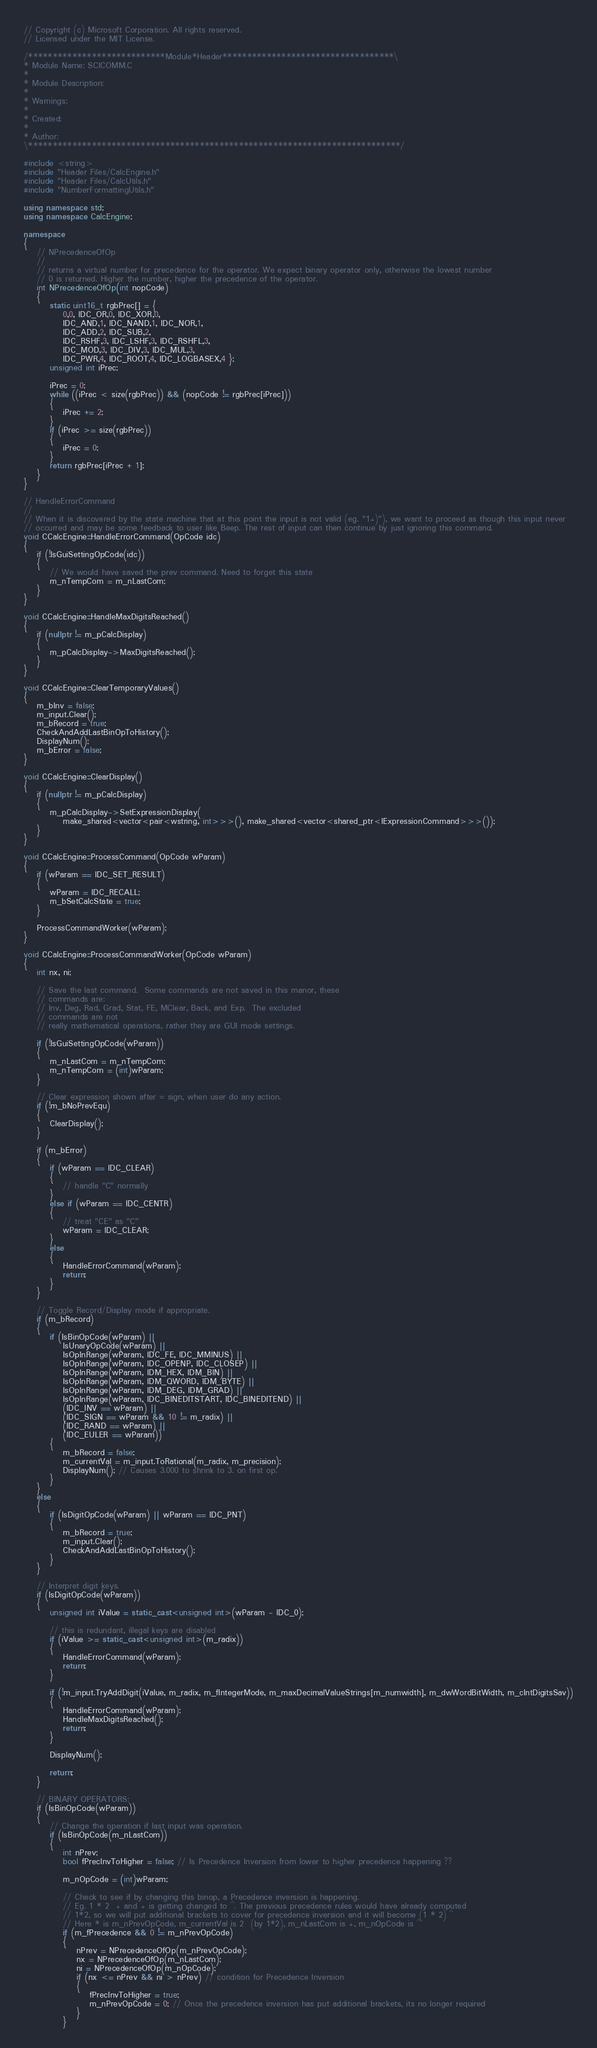<code> <loc_0><loc_0><loc_500><loc_500><_C++_>// Copyright (c) Microsoft Corporation. All rights reserved.
// Licensed under the MIT License.

/****************************Module*Header***********************************\
* Module Name: SCICOMM.C
*
* Module Description:
*
* Warnings:
*
* Created:
*
* Author:
\****************************************************************************/

#include <string>
#include "Header Files/CalcEngine.h"
#include "Header Files/CalcUtils.h"
#include "NumberFormattingUtils.h"

using namespace std;
using namespace CalcEngine;

namespace
{
    // NPrecedenceOfOp
    //
    // returns a virtual number for precedence for the operator. We expect binary operator only, otherwise the lowest number
    // 0 is returned. Higher the number, higher the precedence of the operator.
    int NPrecedenceOfOp(int nopCode)
    {
        static uint16_t rgbPrec[] = {
            0,0, IDC_OR,0, IDC_XOR,0,
            IDC_AND,1, IDC_NAND,1, IDC_NOR,1,
            IDC_ADD,2, IDC_SUB,2,
            IDC_RSHF,3, IDC_LSHF,3, IDC_RSHFL,3,
            IDC_MOD,3, IDC_DIV,3, IDC_MUL,3,
            IDC_PWR,4, IDC_ROOT,4, IDC_LOGBASEX,4 };
        unsigned int iPrec;

        iPrec = 0;
        while ((iPrec < size(rgbPrec)) && (nopCode != rgbPrec[iPrec]))
        {
            iPrec += 2;
        }
        if (iPrec >= size(rgbPrec))
        {
            iPrec = 0;
        }
        return rgbPrec[iPrec + 1];
    }
}

// HandleErrorCommand
//
// When it is discovered by the state machine that at this point the input is not valid (eg. "1+)"), we want to proceed as though this input never
// occurred and may be some feedback to user like Beep. The rest of input can then continue by just ignoring this command.
void CCalcEngine::HandleErrorCommand(OpCode idc)
{
    if (!IsGuiSettingOpCode(idc))
    {
        // We would have saved the prev command. Need to forget this state
        m_nTempCom = m_nLastCom;
    }
}

void CCalcEngine::HandleMaxDigitsReached()
{
    if (nullptr != m_pCalcDisplay)
    {
        m_pCalcDisplay->MaxDigitsReached();
    }
}

void CCalcEngine::ClearTemporaryValues()
{
    m_bInv = false;
    m_input.Clear();
    m_bRecord = true;
    CheckAndAddLastBinOpToHistory();
    DisplayNum();
    m_bError = false;
}

void CCalcEngine::ClearDisplay()
{
    if (nullptr != m_pCalcDisplay)
    {
        m_pCalcDisplay->SetExpressionDisplay(
            make_shared<vector<pair<wstring, int>>>(), make_shared<vector<shared_ptr<IExpressionCommand>>>());
    }
}

void CCalcEngine::ProcessCommand(OpCode wParam)
{
    if (wParam == IDC_SET_RESULT)
    {
        wParam = IDC_RECALL;
        m_bSetCalcState = true;
    }

    ProcessCommandWorker(wParam);
}

void CCalcEngine::ProcessCommandWorker(OpCode wParam)
{
    int nx, ni;

    // Save the last command.  Some commands are not saved in this manor, these
    // commands are:
    // Inv, Deg, Rad, Grad, Stat, FE, MClear, Back, and Exp.  The excluded
    // commands are not
    // really mathematical operations, rather they are GUI mode settings.

    if (!IsGuiSettingOpCode(wParam))
    {
        m_nLastCom = m_nTempCom;
        m_nTempCom = (int)wParam;
    }

    // Clear expression shown after = sign, when user do any action.
    if (!m_bNoPrevEqu)
    {
        ClearDisplay();
    }

    if (m_bError)
    {
        if (wParam == IDC_CLEAR)
        {
            // handle "C" normally
        }
        else if (wParam == IDC_CENTR)
        {
            // treat "CE" as "C"
            wParam = IDC_CLEAR;
        }
        else
        {
            HandleErrorCommand(wParam);
            return;
        }
    }

    // Toggle Record/Display mode if appropriate.
    if (m_bRecord)
    {
        if (IsBinOpCode(wParam) ||
            IsUnaryOpCode(wParam) ||
            IsOpInRange(wParam, IDC_FE, IDC_MMINUS) ||
            IsOpInRange(wParam, IDC_OPENP, IDC_CLOSEP) ||
            IsOpInRange(wParam, IDM_HEX, IDM_BIN) ||
            IsOpInRange(wParam, IDM_QWORD, IDM_BYTE) ||
            IsOpInRange(wParam, IDM_DEG, IDM_GRAD) ||
            IsOpInRange(wParam, IDC_BINEDITSTART, IDC_BINEDITEND) ||
            (IDC_INV == wParam) ||
            (IDC_SIGN == wParam && 10 != m_radix) ||
            (IDC_RAND == wParam) ||
            (IDC_EULER == wParam))
        {
            m_bRecord = false;
            m_currentVal = m_input.ToRational(m_radix, m_precision);
            DisplayNum(); // Causes 3.000 to shrink to 3. on first op.
        }
    }
    else
    {
        if (IsDigitOpCode(wParam) || wParam == IDC_PNT)
        {
            m_bRecord = true;
            m_input.Clear();
            CheckAndAddLastBinOpToHistory();
        }
    }

    // Interpret digit keys.
    if (IsDigitOpCode(wParam))
    {
        unsigned int iValue = static_cast<unsigned int>(wParam - IDC_0);

        // this is redundant, illegal keys are disabled
        if (iValue >= static_cast<unsigned int>(m_radix))
        {
            HandleErrorCommand(wParam);
            return;
        }

        if (!m_input.TryAddDigit(iValue, m_radix, m_fIntegerMode, m_maxDecimalValueStrings[m_numwidth], m_dwWordBitWidth, m_cIntDigitsSav))
        {
            HandleErrorCommand(wParam);
            HandleMaxDigitsReached();
            return;
        }

        DisplayNum();

        return;
    }

    // BINARY OPERATORS:
    if (IsBinOpCode(wParam))
    {
        // Change the operation if last input was operation.
        if (IsBinOpCode(m_nLastCom))
        {
            int nPrev;
            bool fPrecInvToHigher = false; // Is Precedence Inversion from lower to higher precedence happening ??

            m_nOpCode = (int)wParam;

            // Check to see if by changing this binop, a Precedence inversion is happening.
            // Eg. 1 * 2  + and + is getting changed to ^. The previous precedence rules would have already computed
            // 1*2, so we will put additional brackets to cover for precedence inversion and it will become (1 * 2) ^
            // Here * is m_nPrevOpCode, m_currentVal is 2  (by 1*2), m_nLastCom is +, m_nOpCode is ^
            if (m_fPrecedence && 0 != m_nPrevOpCode)
            {
                nPrev = NPrecedenceOfOp(m_nPrevOpCode);
                nx = NPrecedenceOfOp(m_nLastCom);
                ni = NPrecedenceOfOp(m_nOpCode);
                if (nx <= nPrev && ni > nPrev) // condition for Precedence Inversion
                {
                    fPrecInvToHigher = true;
                    m_nPrevOpCode = 0; // Once the precedence inversion has put additional brackets, its no longer required
                }
            }</code> 